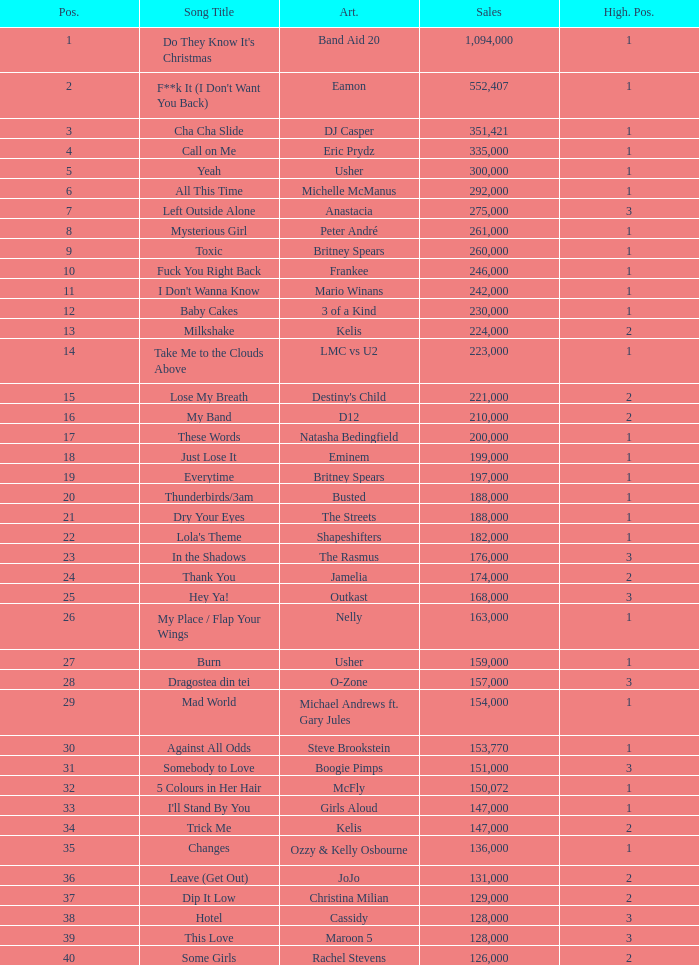What were the sales for Dj Casper when he was in a position lower than 13? 351421.0. 